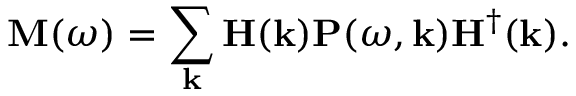Convert formula to latex. <formula><loc_0><loc_0><loc_500><loc_500>M ( \omega ) = \sum _ { k } H ( k ) P ( \omega , k ) H ^ { \dagger } ( k ) .</formula> 